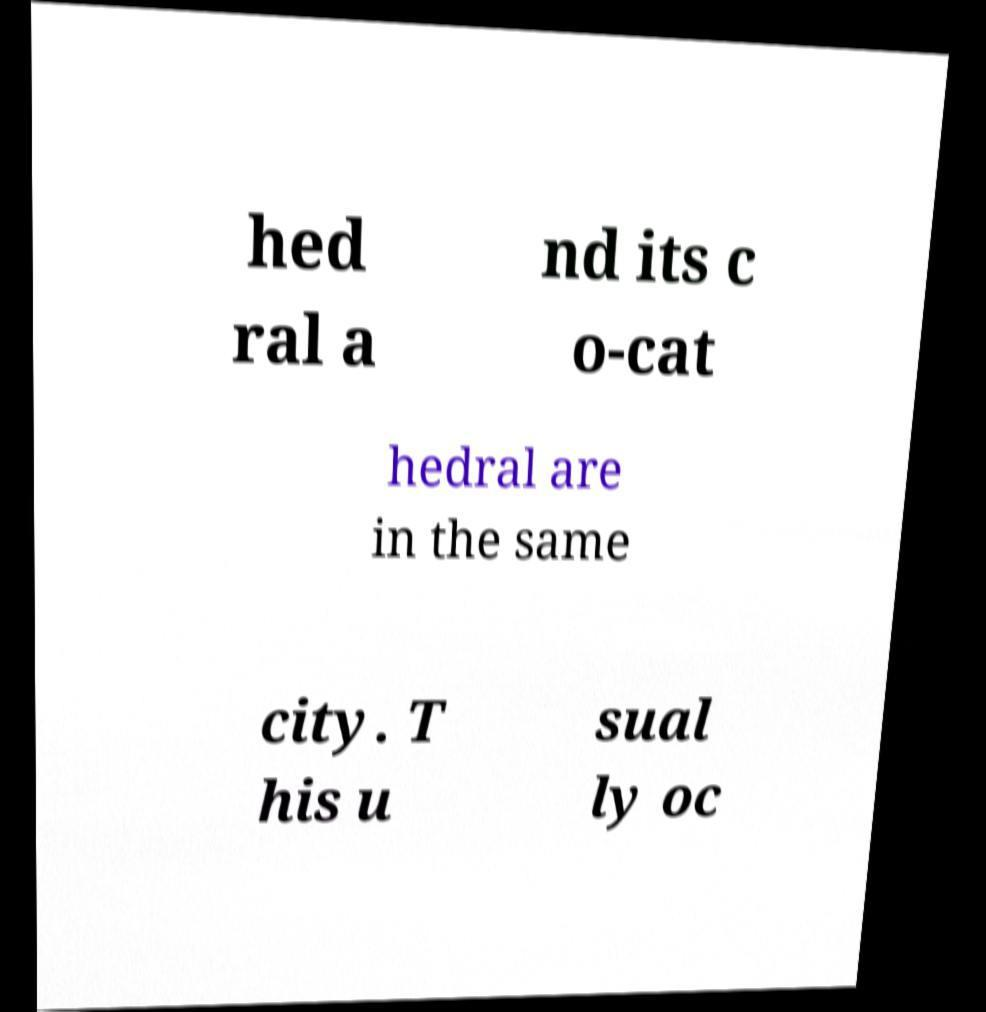Could you extract and type out the text from this image? hed ral a nd its c o-cat hedral are in the same city. T his u sual ly oc 